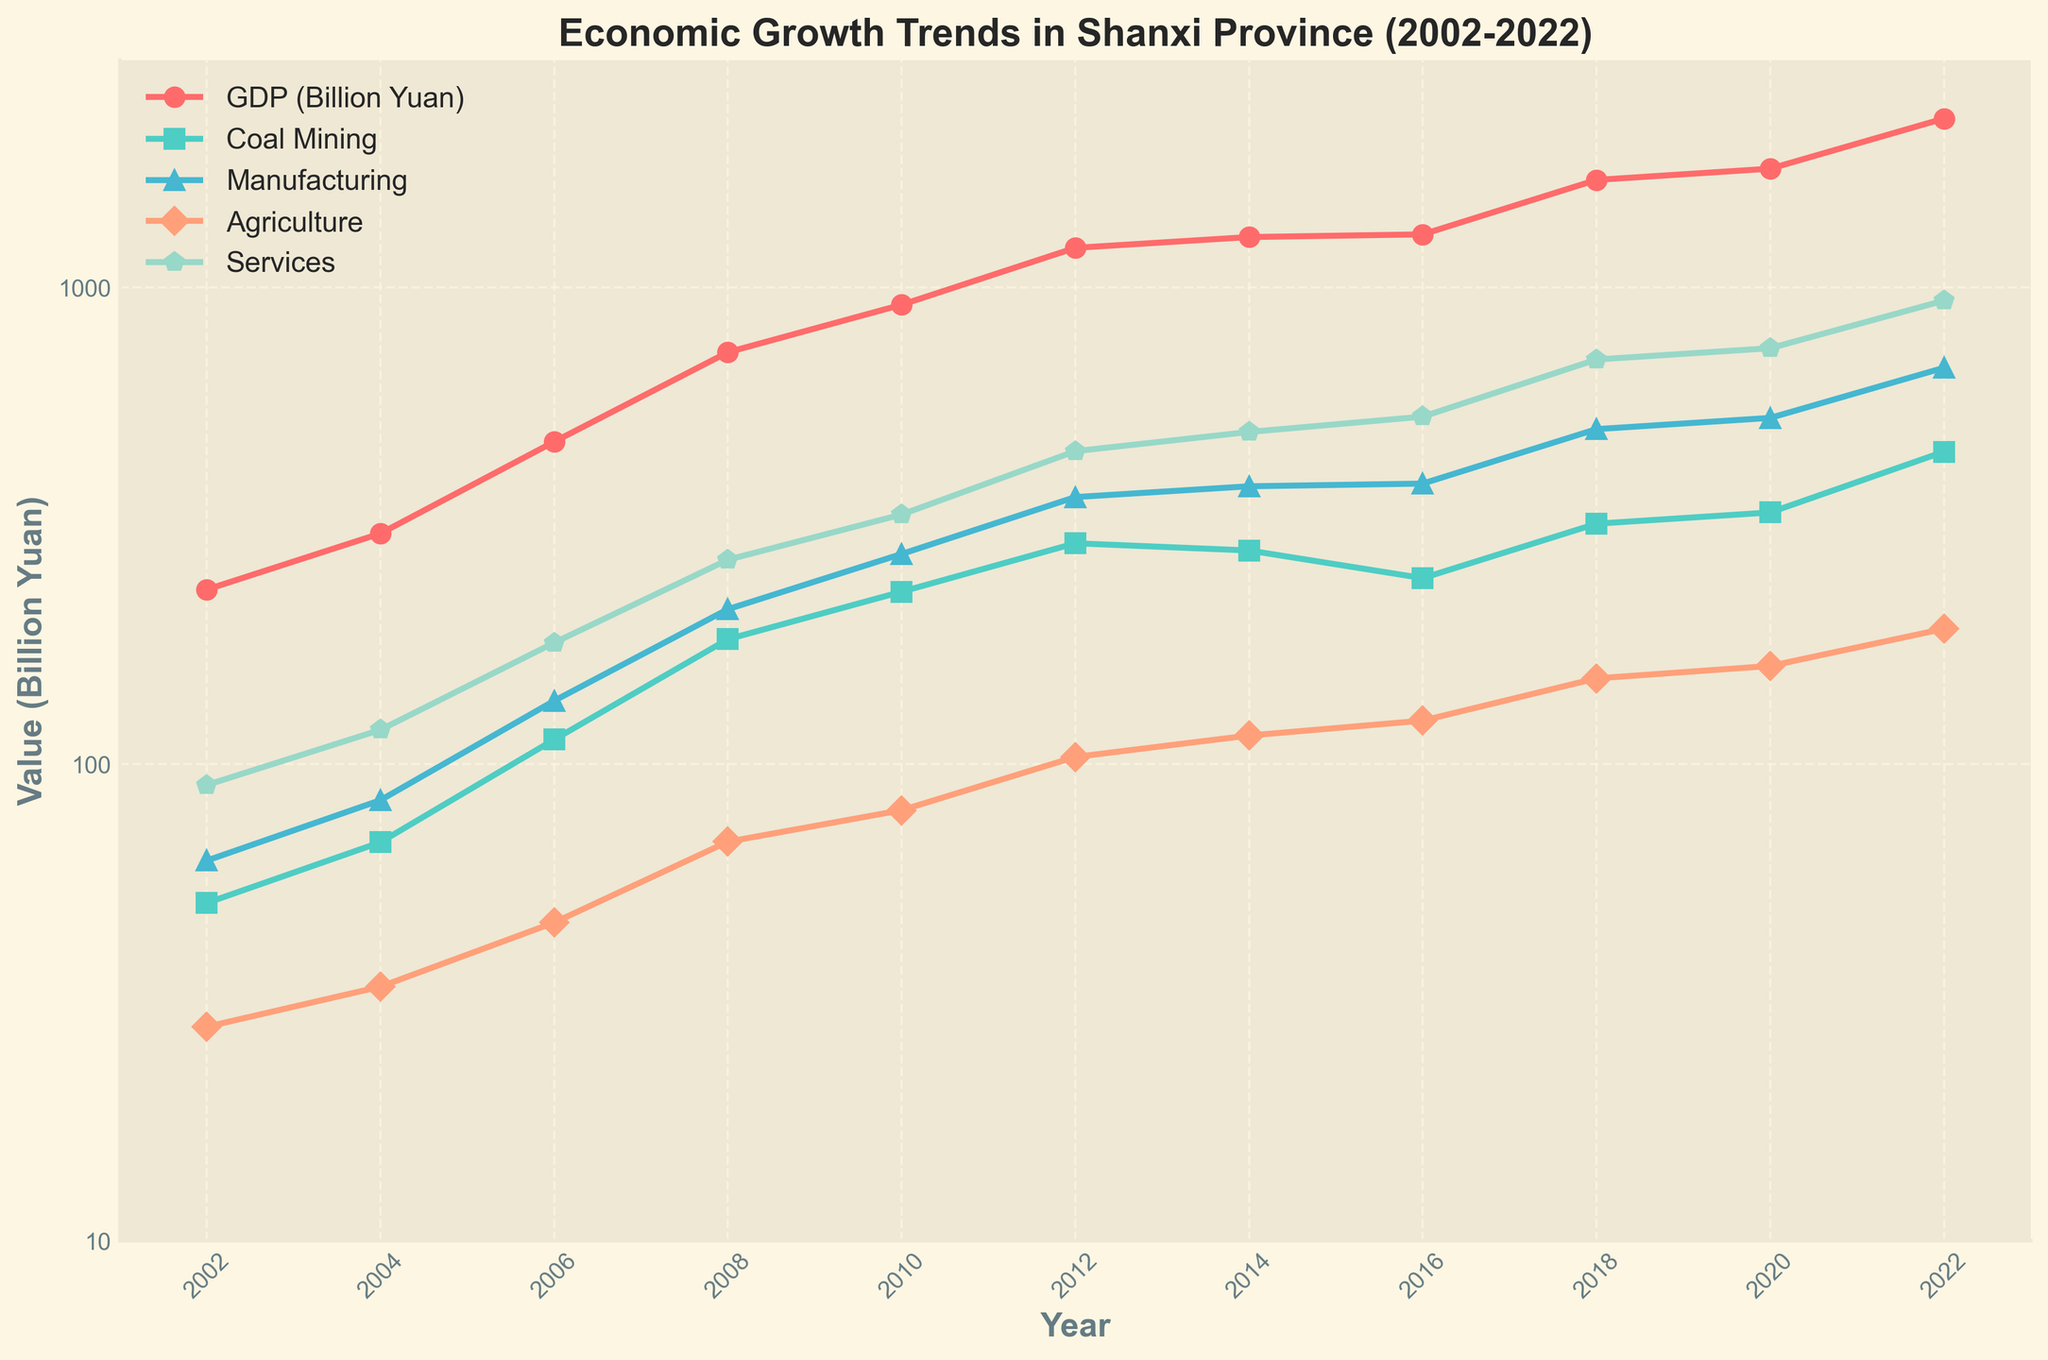What is the total GDP of Shanxi Province in 2022? From the plot, locate the 2022 data point along the x-axis. Find the corresponding GDP value, indicated by the red line and marked with an 'o'.
Answer: 2262 Billion Yuan Which industry sector showed the highest value in 2018? Find the year 2018 on the x-axis. Compare the data points for all sectors in 2018 and identify the highest. The services sector, represented by the teal diamond, is the highest.
Answer: Services How did the value of the manufacturing sector change between 2002 and 2022? Locate the values of the manufacturing sector for the years 2002 and 2022. The values are 62.75 Billion Yuan in 2002 and 678.60 Billion Yuan in 2022, indicating an increase. Calculate the difference: 678.60 - 62.75 = 615.85.
Answer: Increased by 615.85 Billion Yuan What is the average GDP growth rate between 2010 and 2020? Identify the GDP values for 2010 and 2020 (920.08 and 1775.68 Billion Yuan). Calculate the growth rate: (1775.68 - 920.08) / 10 years. The average growth rate per year is (855.6 / 10) ≈ 85.56 Billion Yuan per year.
Answer: ~85.56 Billion Yuan per year Which sector experienced the most significant decline from a peak value, and in which year did this decline start? Look at each sector's trend to identify a peak followed by a decline. The coal mining sector peaked in 2012 at 290.71 Billion Yuan and declined afterward.
Answer: Coal mining, starting in 2012 During which period did the services sector see the highest rate of growth, and how much did it grow? Compare the increments between adjacent years for the services sector. The highest growth is between 2016 (535.93) and 2018 (706.37). Calculate the difference: 706.37 - 535.93 = 170.44 Billion Yuan.
Answer: Between 2016 and 2018, 170.44 Billion Yuan What was the GDP in 2008, and how did it compare to the GDP in 2014? Locate the GDP values for the years 2008 and 2014 (731.46 and 1276.11 Billion Yuan). Subtract 2008's GDP from 2014's GDP: 1276.11 - 731.46 = 544.65.
Answer: 544.65 Billion Yuan higher in 2014 How does the value of agriculture in 2022 compare to its value in 2002? Find the agriculture sector data points for 2022 and 2002 (192.27 and 28.12 Billion Yuan). Calculate the difference: 192.27 - 28.12 = 164.15.
Answer: Increased by 164.15 Billion Yuan What is the proportion of services to the total GDP in 2022? Identify the services and GDP values for 2022 (938.73 and 2262 Billion Yuan). Calculate the proportion: 938.73 / 2262 ≈ 0.4147, or about 41.47%.
Answer: ~41.47% Which sector's growth trend had the most fluctuations, and how can you describe the pattern? By visually examining the line patterns, the coal mining sector shows significant fluctuations with peaks and declines, especially after 2012. This pattern is irregular compared to others.
Answer: Coal mining, irregular with peaks and declines 